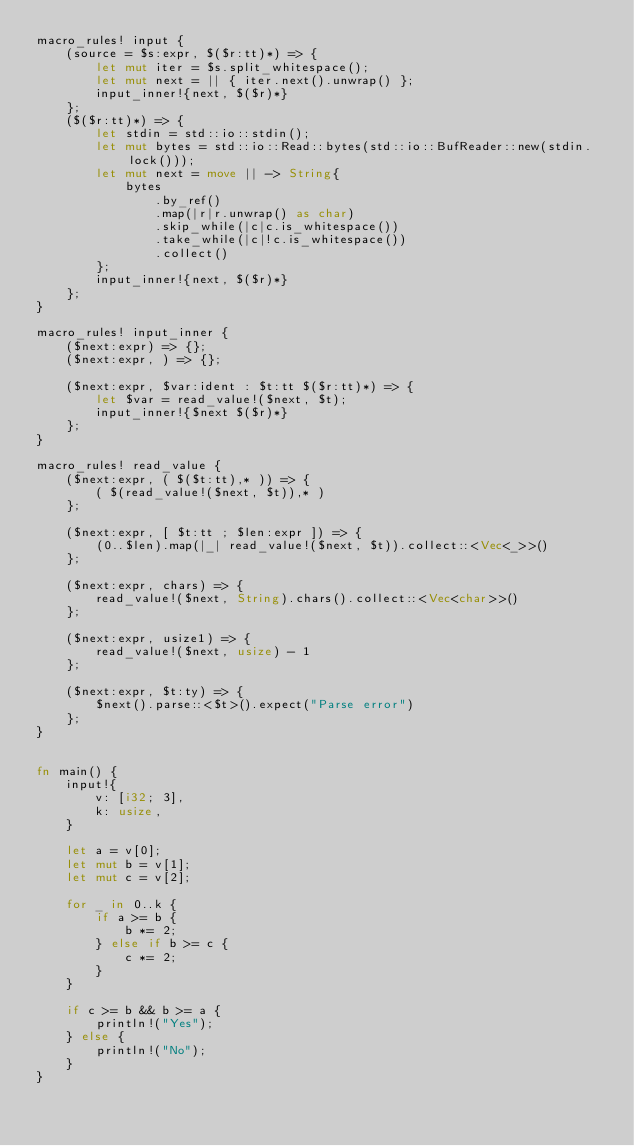<code> <loc_0><loc_0><loc_500><loc_500><_Rust_>macro_rules! input {
    (source = $s:expr, $($r:tt)*) => {
        let mut iter = $s.split_whitespace();
        let mut next = || { iter.next().unwrap() };
        input_inner!{next, $($r)*}
    };
    ($($r:tt)*) => {
        let stdin = std::io::stdin();
        let mut bytes = std::io::Read::bytes(std::io::BufReader::new(stdin.lock()));
        let mut next = move || -> String{
            bytes
                .by_ref()
                .map(|r|r.unwrap() as char)
                .skip_while(|c|c.is_whitespace())
                .take_while(|c|!c.is_whitespace())
                .collect()
        };
        input_inner!{next, $($r)*}
    };
}

macro_rules! input_inner {
    ($next:expr) => {};
    ($next:expr, ) => {};

    ($next:expr, $var:ident : $t:tt $($r:tt)*) => {
        let $var = read_value!($next, $t);
        input_inner!{$next $($r)*}
    };
}

macro_rules! read_value {
    ($next:expr, ( $($t:tt),* )) => {
        ( $(read_value!($next, $t)),* )
    };

    ($next:expr, [ $t:tt ; $len:expr ]) => {
        (0..$len).map(|_| read_value!($next, $t)).collect::<Vec<_>>()
    };

    ($next:expr, chars) => {
        read_value!($next, String).chars().collect::<Vec<char>>()
    };

    ($next:expr, usize1) => {
        read_value!($next, usize) - 1
    };

    ($next:expr, $t:ty) => {
        $next().parse::<$t>().expect("Parse error")
    };
}


fn main() {
    input!{
        v: [i32; 3],
        k: usize,
    }

    let a = v[0];
    let mut b = v[1];
    let mut c = v[2];

    for _ in 0..k {
        if a >= b {
            b *= 2;
        } else if b >= c {
            c *= 2;
        }
    }

    if c >= b && b >= a {
        println!("Yes");
    } else {
        println!("No");
    }
}
</code> 